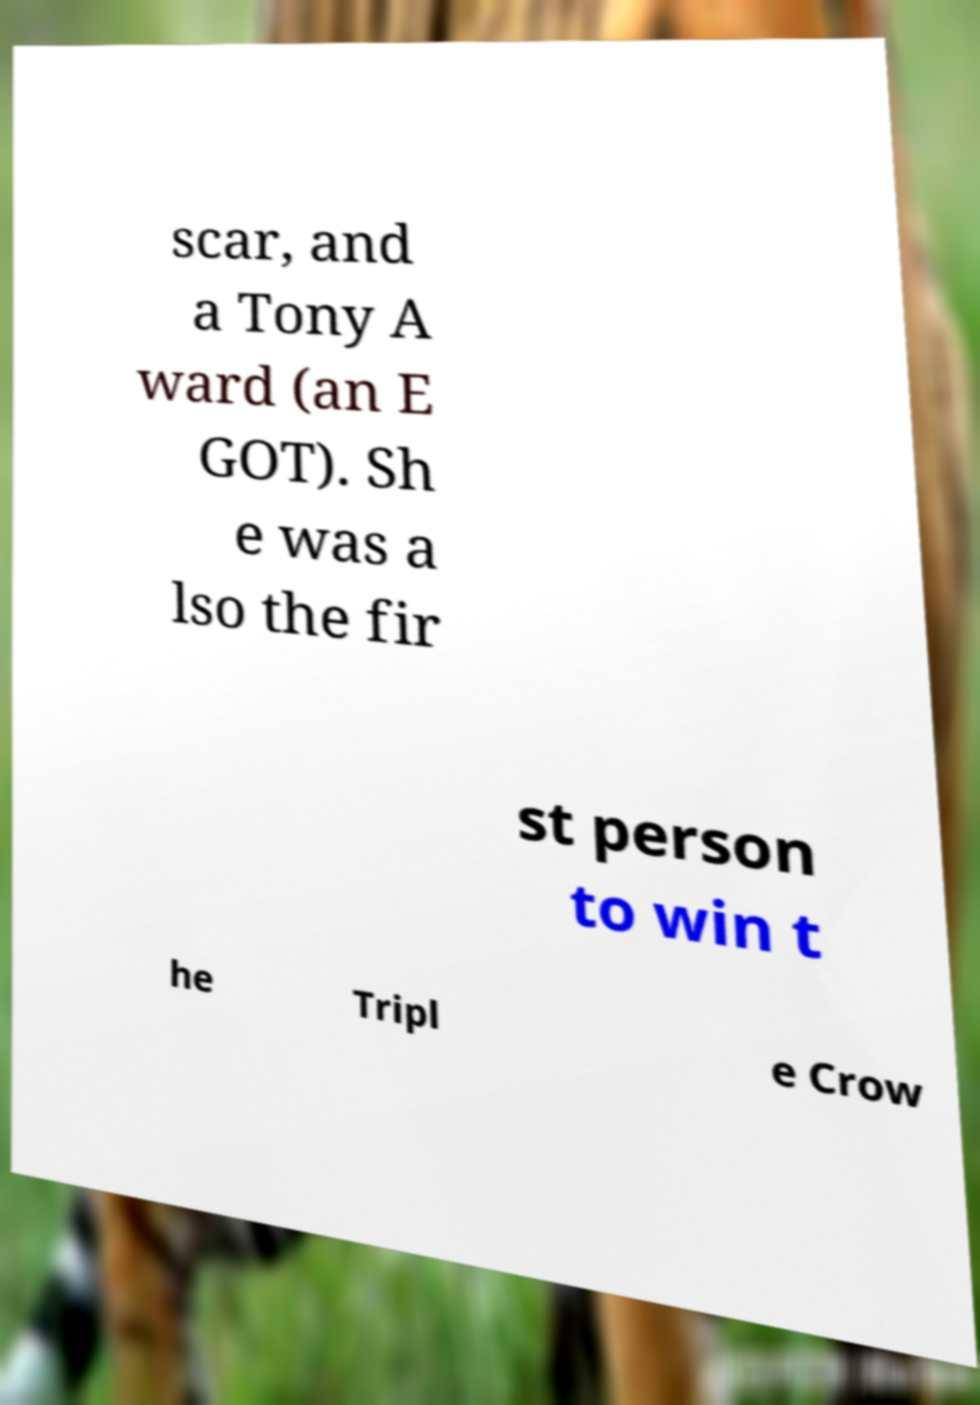Please read and relay the text visible in this image. What does it say? scar, and a Tony A ward (an E GOT). Sh e was a lso the fir st person to win t he Tripl e Crow 